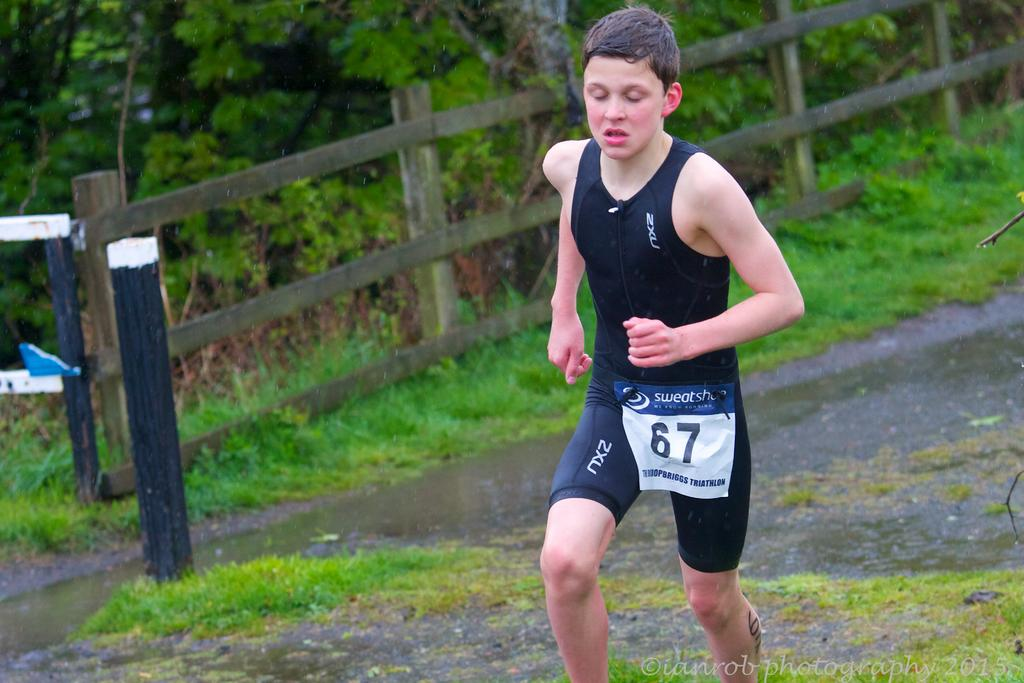Who is the main subject in the image? There is a boy in the image. What is the boy doing in the image? The boy is running on the ground. What can be seen behind the boy? There is water visible behind the boy. What architectural or natural elements can be seen in the background of the image? There is a wooden railing and trees visible in the background of the image. What type of wine is the boy holding in the image? There is no wine present in the image; the boy is running and does not have any objects in his hands. 